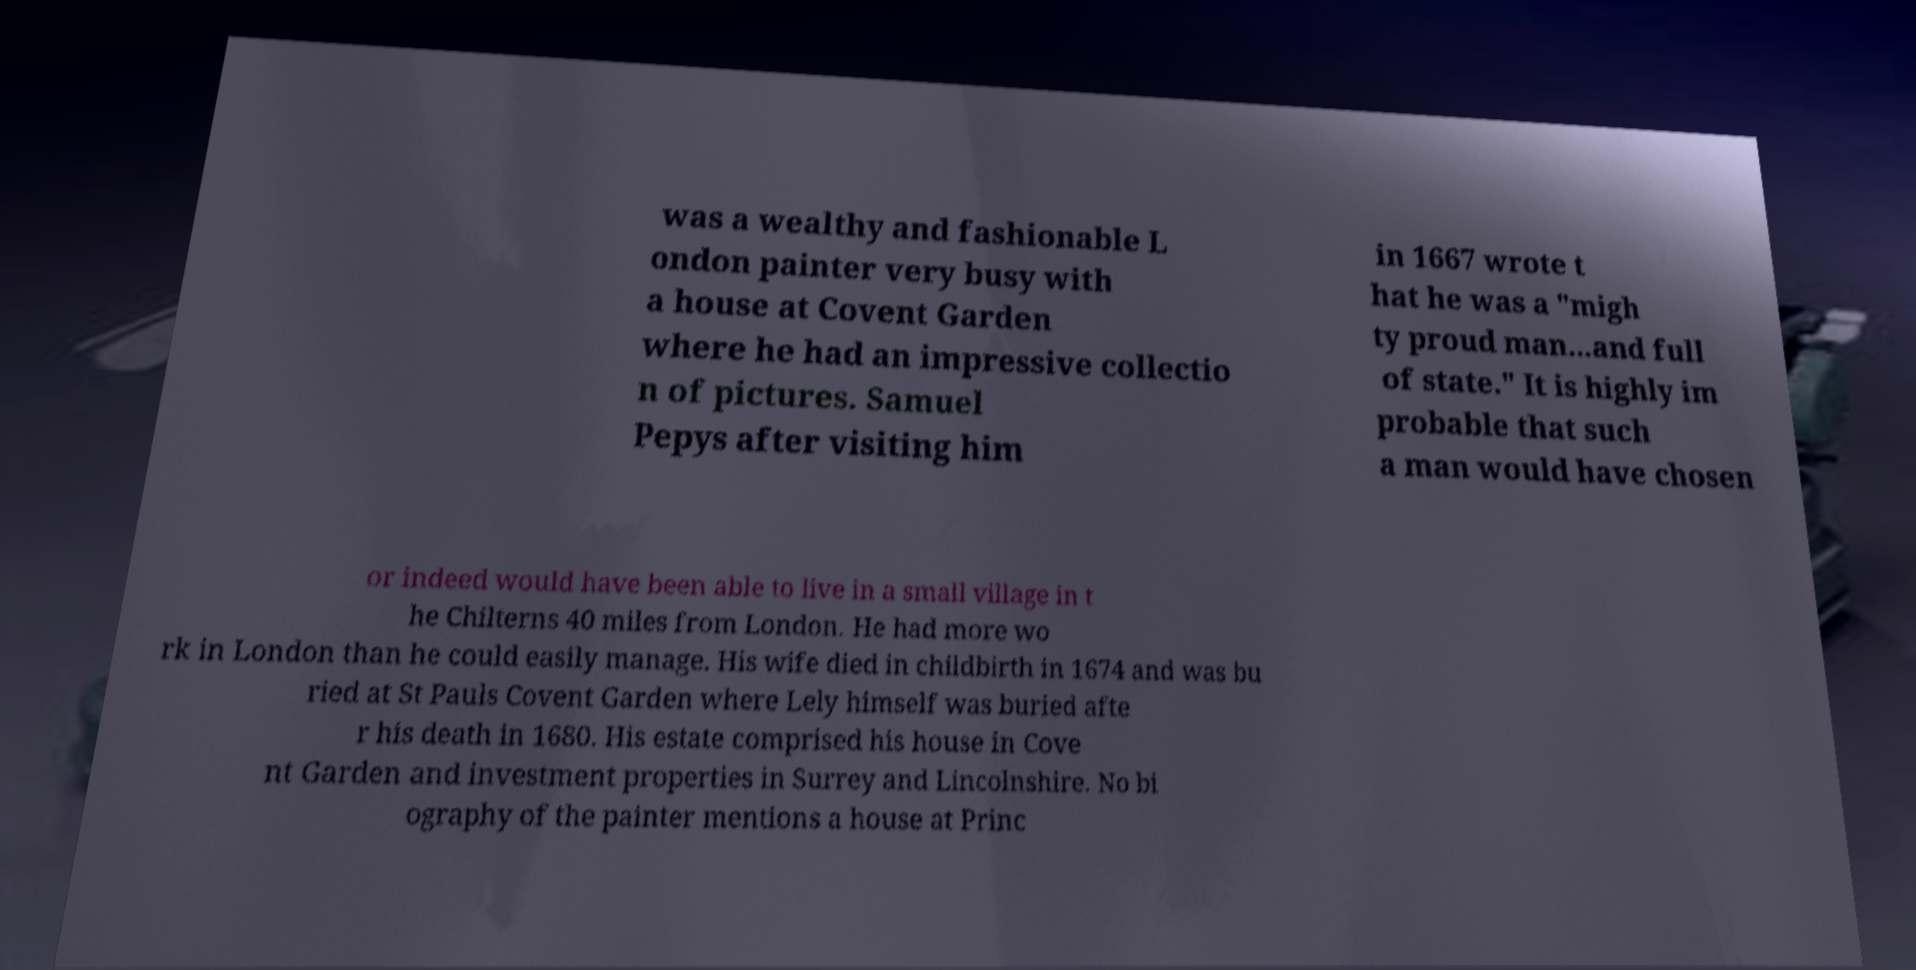There's text embedded in this image that I need extracted. Can you transcribe it verbatim? was a wealthy and fashionable L ondon painter very busy with a house at Covent Garden where he had an impressive collectio n of pictures. Samuel Pepys after visiting him in 1667 wrote t hat he was a "migh ty proud man...and full of state." It is highly im probable that such a man would have chosen or indeed would have been able to live in a small village in t he Chilterns 40 miles from London. He had more wo rk in London than he could easily manage. His wife died in childbirth in 1674 and was bu ried at St Pauls Covent Garden where Lely himself was buried afte r his death in 1680. His estate comprised his house in Cove nt Garden and investment properties in Surrey and Lincolnshire. No bi ography of the painter mentions a house at Princ 